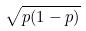Convert formula to latex. <formula><loc_0><loc_0><loc_500><loc_500>\sqrt { p ( 1 - p ) }</formula> 